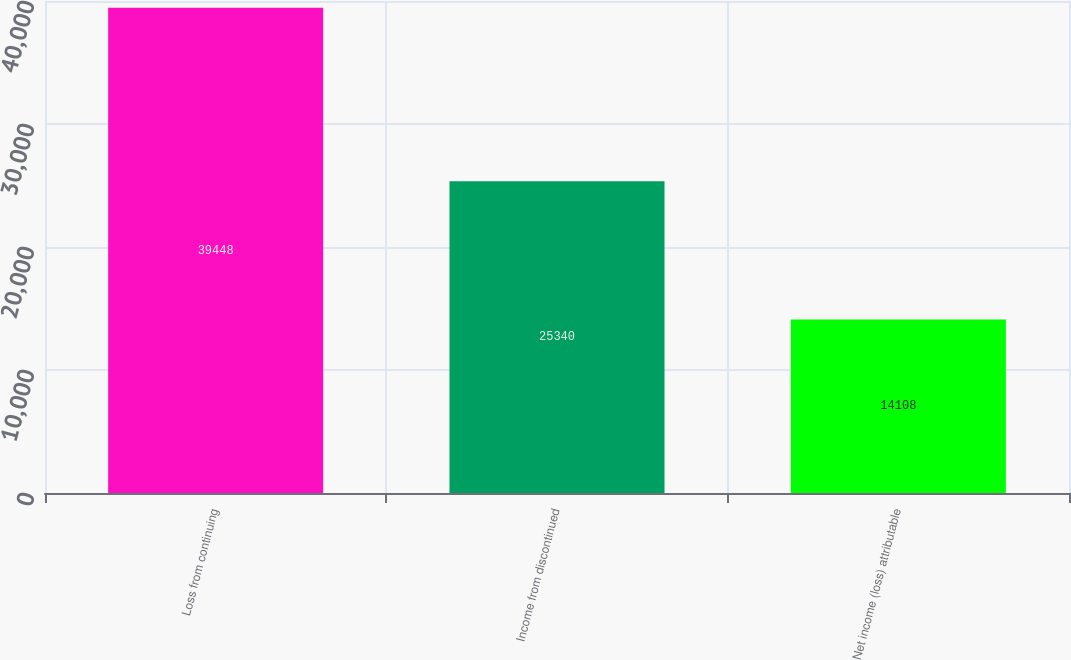Convert chart. <chart><loc_0><loc_0><loc_500><loc_500><bar_chart><fcel>Loss from continuing<fcel>Income from discontinued<fcel>Net income (loss) attributable<nl><fcel>39448<fcel>25340<fcel>14108<nl></chart> 